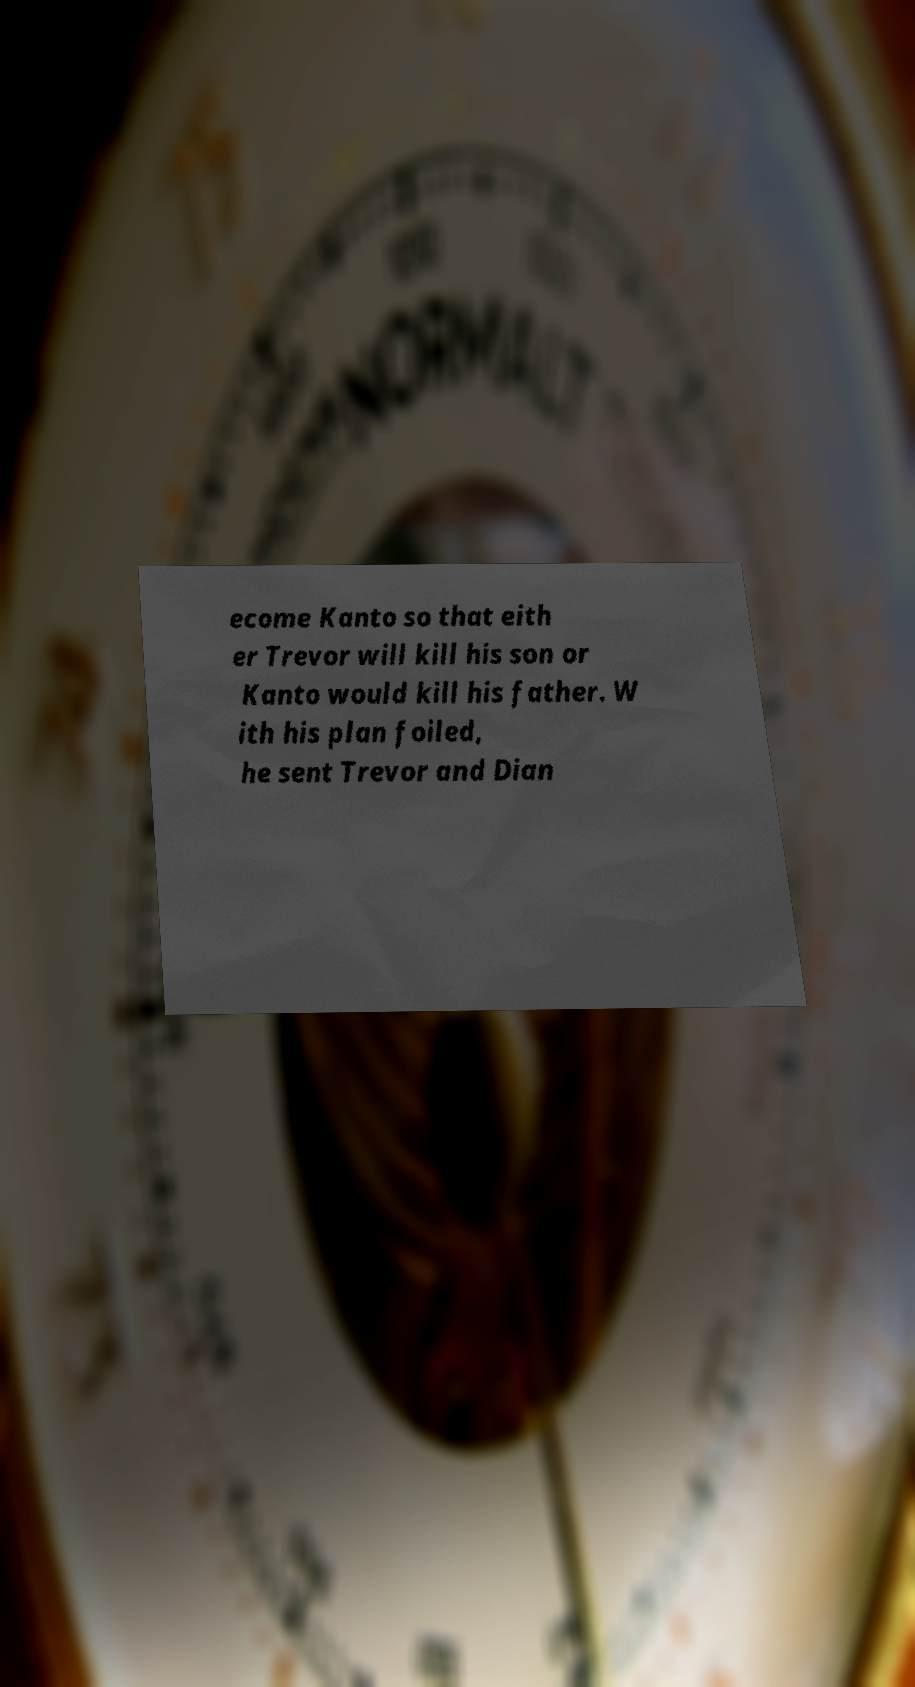Could you extract and type out the text from this image? ecome Kanto so that eith er Trevor will kill his son or Kanto would kill his father. W ith his plan foiled, he sent Trevor and Dian 